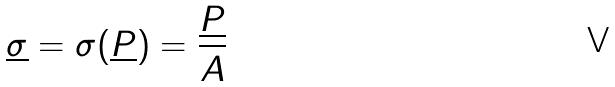Convert formula to latex. <formula><loc_0><loc_0><loc_500><loc_500>\underline { \sigma } = \sigma ( \underline { P } ) = \frac { \underline { P } } { A }</formula> 